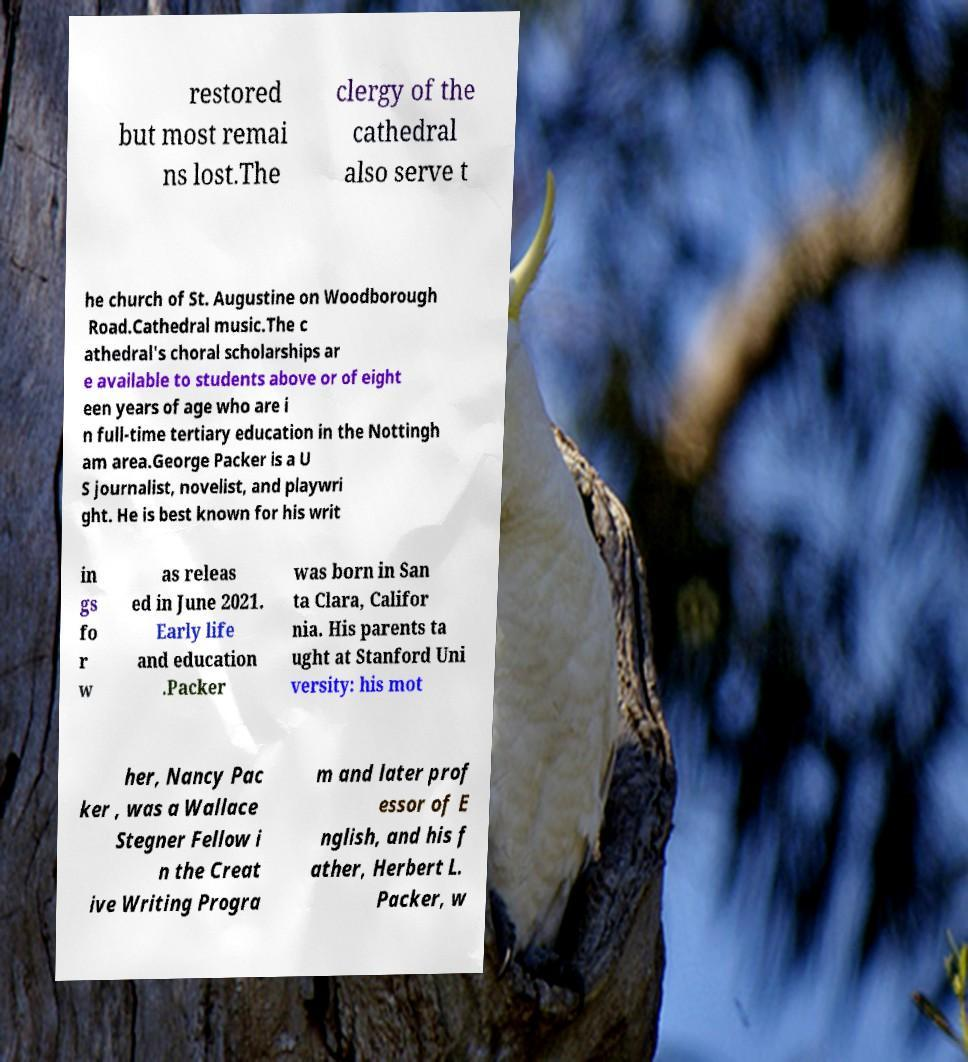Please read and relay the text visible in this image. What does it say? restored but most remai ns lost.The clergy of the cathedral also serve t he church of St. Augustine on Woodborough Road.Cathedral music.The c athedral's choral scholarships ar e available to students above or of eight een years of age who are i n full-time tertiary education in the Nottingh am area.George Packer is a U S journalist, novelist, and playwri ght. He is best known for his writ in gs fo r w as releas ed in June 2021. Early life and education .Packer was born in San ta Clara, Califor nia. His parents ta ught at Stanford Uni versity: his mot her, Nancy Pac ker , was a Wallace Stegner Fellow i n the Creat ive Writing Progra m and later prof essor of E nglish, and his f ather, Herbert L. Packer, w 